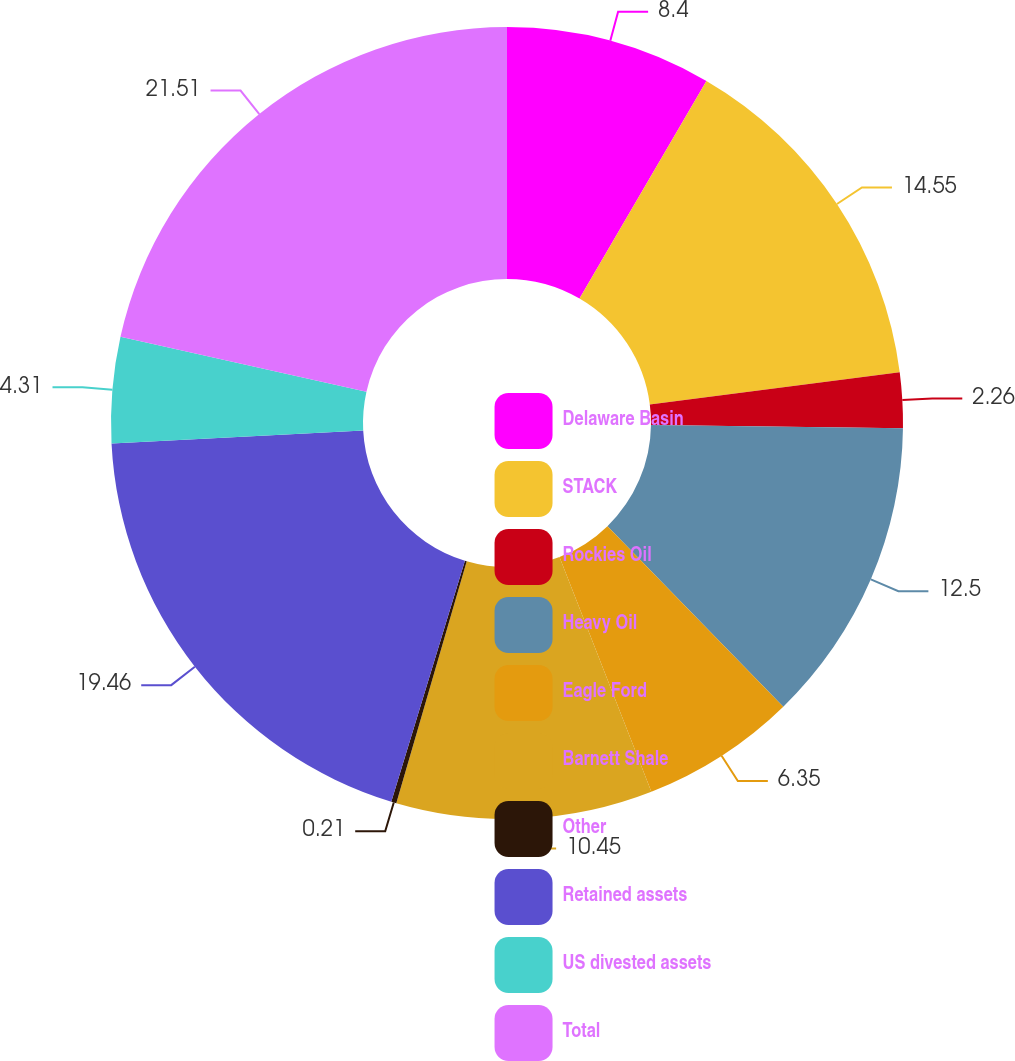<chart> <loc_0><loc_0><loc_500><loc_500><pie_chart><fcel>Delaware Basin<fcel>STACK<fcel>Rockies Oil<fcel>Heavy Oil<fcel>Eagle Ford<fcel>Barnett Shale<fcel>Other<fcel>Retained assets<fcel>US divested assets<fcel>Total<nl><fcel>8.4%<fcel>14.55%<fcel>2.26%<fcel>12.5%<fcel>6.35%<fcel>10.45%<fcel>0.21%<fcel>19.46%<fcel>4.31%<fcel>21.51%<nl></chart> 